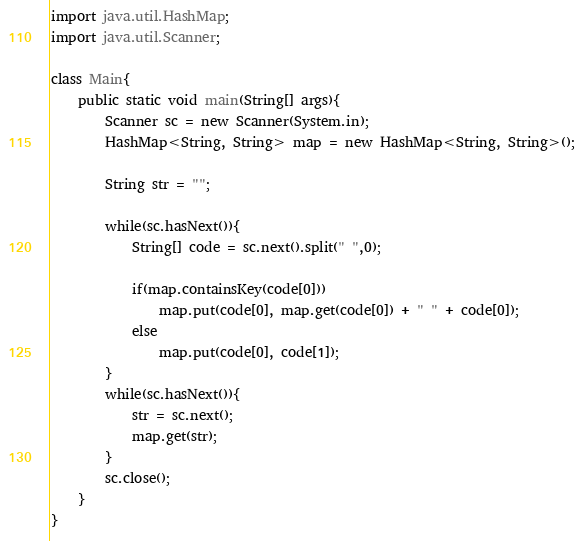<code> <loc_0><loc_0><loc_500><loc_500><_Java_>import java.util.HashMap;
import java.util.Scanner;

class Main{
	public static void main(String[] args){
		Scanner sc = new Scanner(System.in);
		HashMap<String, String> map = new HashMap<String, String>();
		
		String str = "";
		
		while(sc.hasNext()){
			String[] code = sc.next().split(" ",0);
			
			if(map.containsKey(code[0]))
				map.put(code[0], map.get(code[0]) + " " + code[0]);
			else
				map.put(code[0], code[1]);
		}
		while(sc.hasNext()){
			str = sc.next();
			map.get(str);
		}
		sc.close();
	}
}</code> 